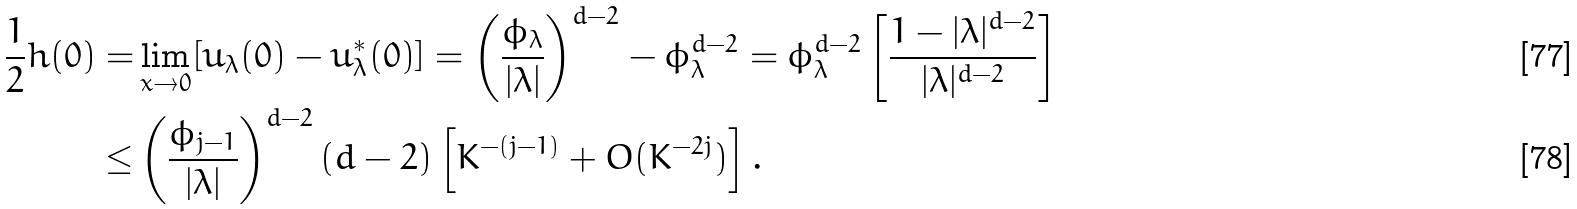<formula> <loc_0><loc_0><loc_500><loc_500>\frac { 1 } { 2 } h ( 0 ) = & \lim _ { x \rightarrow 0 } [ u _ { \lambda } ( 0 ) - u ^ { * } _ { \lambda } ( 0 ) ] = \left ( \frac { \phi _ { \lambda } } { | \lambda | } \right ) ^ { d - 2 } - \phi _ { \lambda } ^ { d - 2 } = \phi _ { \lambda } ^ { d - 2 } \left [ \frac { 1 - | \lambda | ^ { d - 2 } } { | \lambda | ^ { d - 2 } } \right ] \\ \leq & \left ( \frac { \phi _ { j - 1 } } { | \lambda | } \right ) ^ { d - 2 } ( d - 2 ) \left [ K ^ { - ( j - 1 ) } + O ( K ^ { - 2 j } ) \right ] .</formula> 